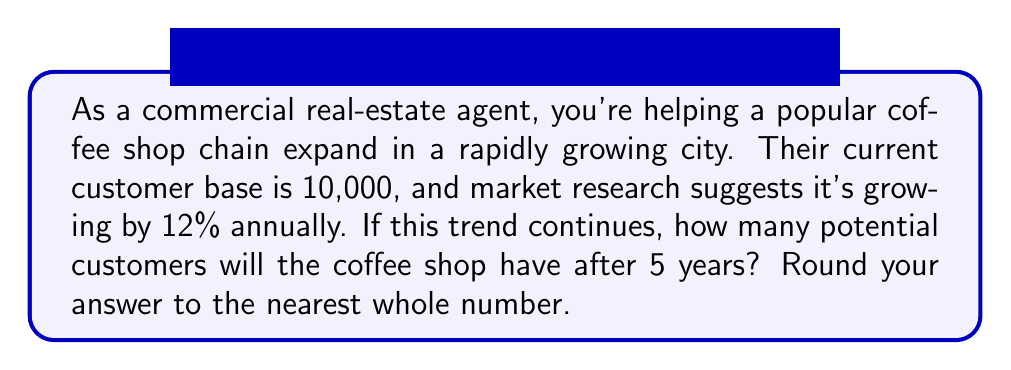What is the answer to this math problem? To solve this problem, we'll use an exponential growth model. The general form of an exponential growth model is:

$$A = P(1 + r)^t$$

Where:
$A$ = Final amount
$P$ = Initial amount (principal)
$r$ = Growth rate (as a decimal)
$t$ = Time period

Given:
$P = 10,000$ (initial customer base)
$r = 0.12$ (12% annual growth rate)
$t = 5$ years

Let's plug these values into our equation:

$$A = 10,000(1 + 0.12)^5$$

Now, let's solve step-by-step:

1) First, calculate $(1 + 0.12)^5$:
   $$(1.12)^5 = 1.7623416$$

2) Multiply this by the initial customer base:
   $$10,000 \times 1.7623416 = 17,623.416$$

3) Round to the nearest whole number:
   $$17,623.416 \approx 17,623$$

Therefore, after 5 years, the potential customer base will be approximately 17,623 people.
Answer: 17,623 potential customers 